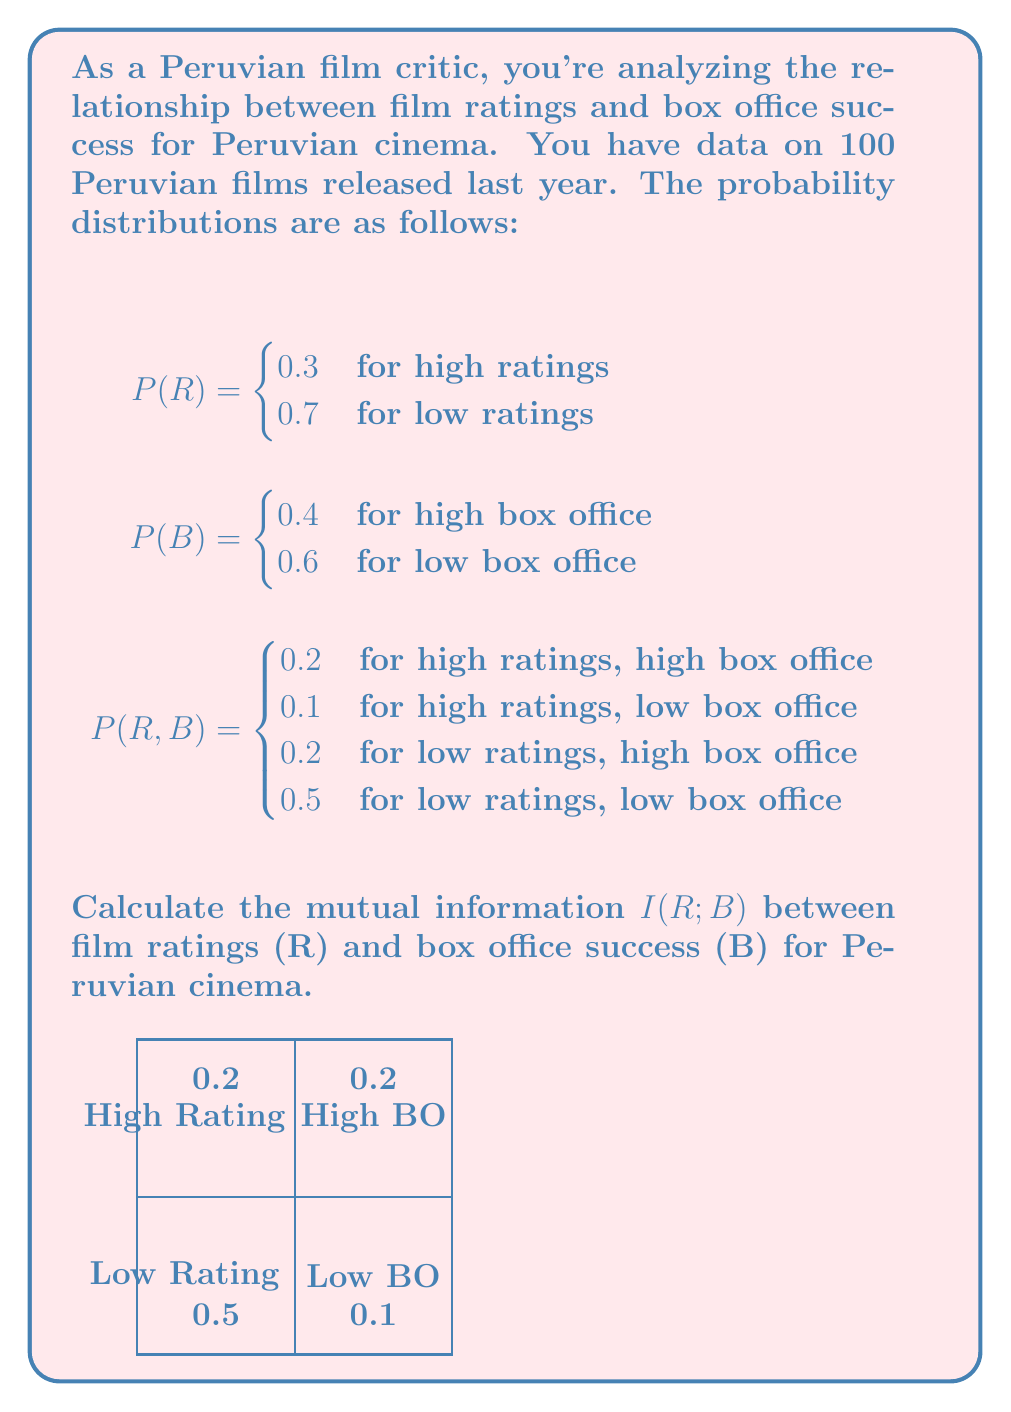Help me with this question. To calculate the mutual information $I(R;B)$, we'll use the formula:

$$I(R;B) = \sum_{r \in R} \sum_{b \in B} P(r,b) \log_2 \frac{P(r,b)}{P(r)P(b)}$$

Step 1: Calculate $P(r)P(b)$ for each combination:
- $P(high,high) = 0.3 \times 0.4 = 0.12$
- $P(high,low) = 0.3 \times 0.6 = 0.18$
- $P(low,high) = 0.7 \times 0.4 = 0.28$
- $P(low,low) = 0.7 \times 0.6 = 0.42$

Step 2: Calculate $\frac{P(r,b)}{P(r)P(b)}$ for each combination:
- High rating, high BO: $\frac{0.2}{0.12} \approx 1.6667$
- High rating, low BO: $\frac{0.1}{0.18} \approx 0.5556$
- Low rating, high BO: $\frac{0.2}{0.28} \approx 0.7143$
- Low rating, low BO: $\frac{0.5}{0.42} \approx 1.1905$

Step 3: Calculate each term in the sum:
- $0.2 \log_2(1.6667) \approx 0.2 \times 0.7370 = 0.1474$
- $0.1 \log_2(0.5556) \approx 0.1 \times (-0.8480) = -0.0848$
- $0.2 \log_2(0.7143) \approx 0.2 \times (-0.4854) = -0.0971$
- $0.5 \log_2(1.1905) \approx 0.5 \times 0.2516 = 0.1258$

Step 4: Sum all terms:
$I(R;B) = 0.1474 - 0.0848 - 0.0971 + 0.1258 = 0.0913$ bits

Therefore, the mutual information between film ratings and box office success for Peruvian cinema is approximately 0.0913 bits.
Answer: $0.0913$ bits 